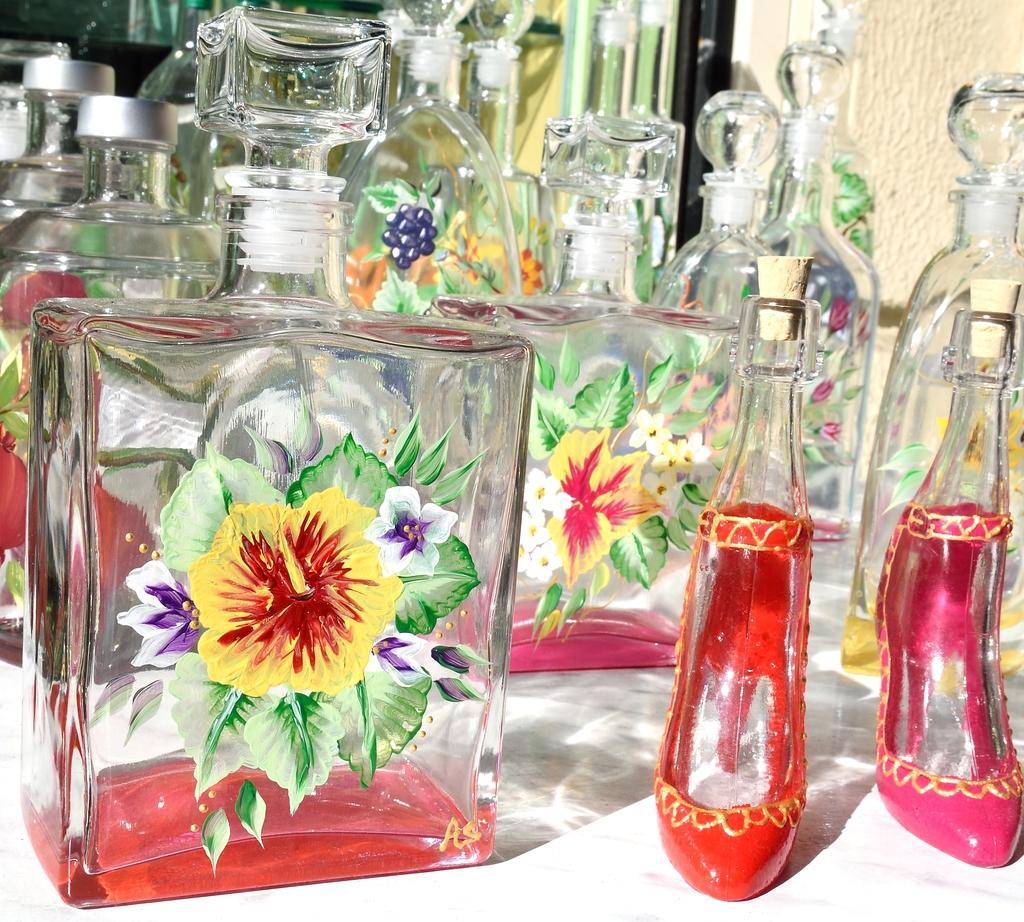Please provide a concise description of this image. In this picture there are different types of perfume bottles kept on a table. 